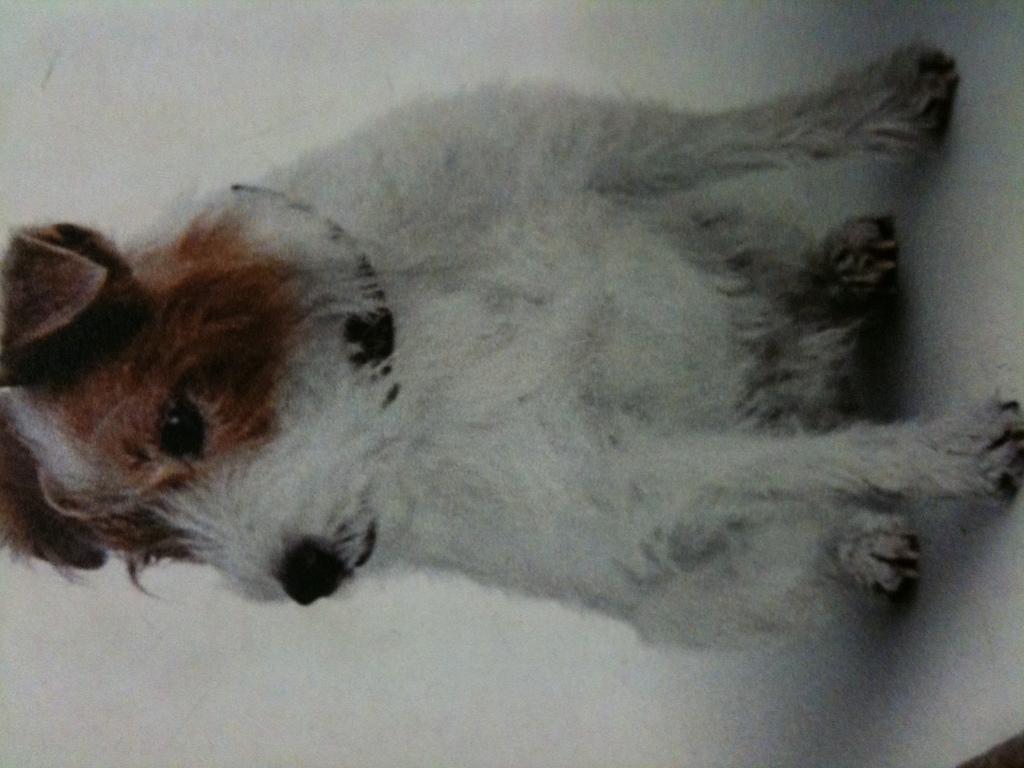In one or two sentences, can you explain what this image depicts? In this image we can see a dog sitting on the table. 